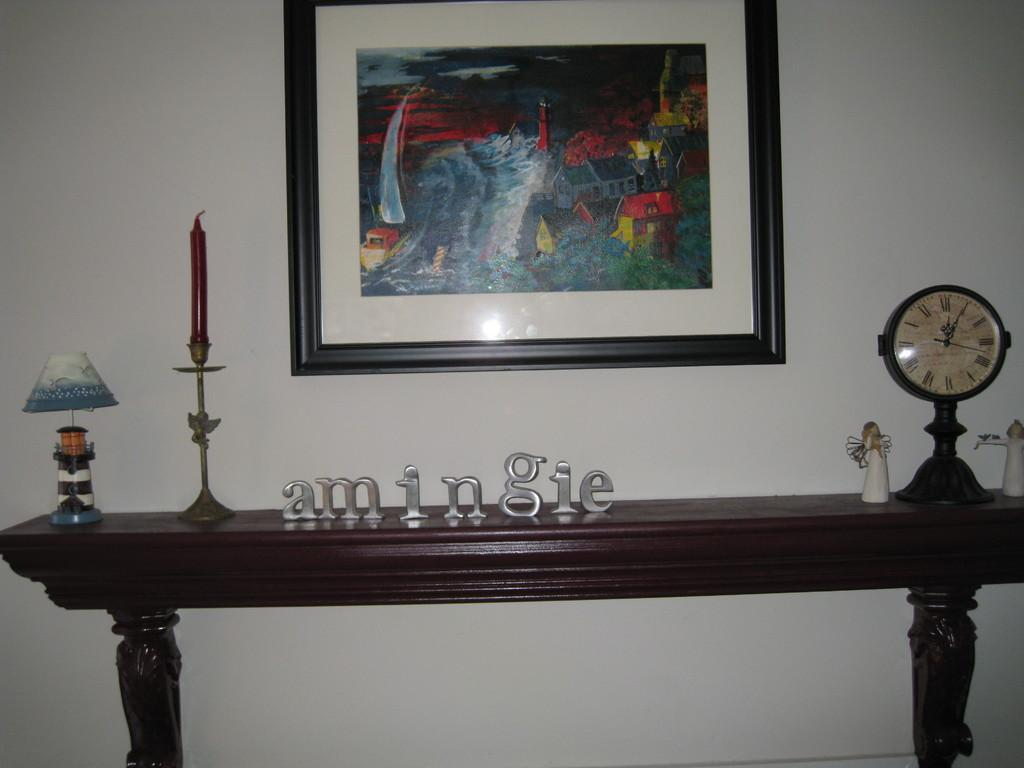<image>
Write a terse but informative summary of the picture. A side table in a home has the word AMINGIE arranged on it. 